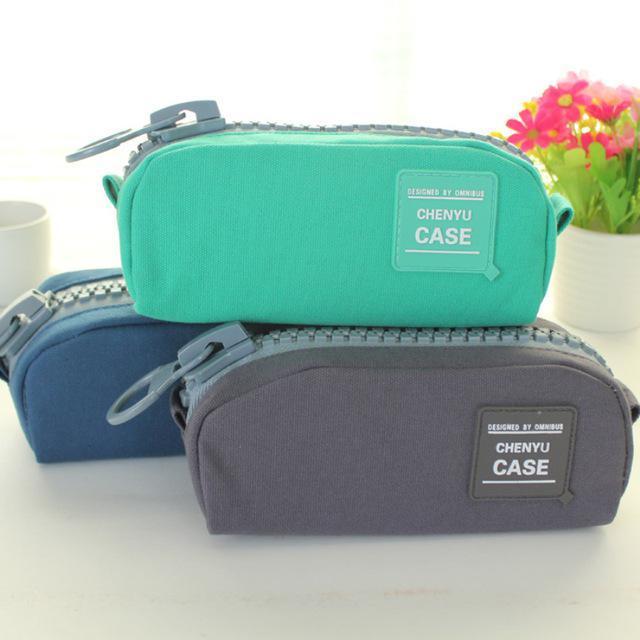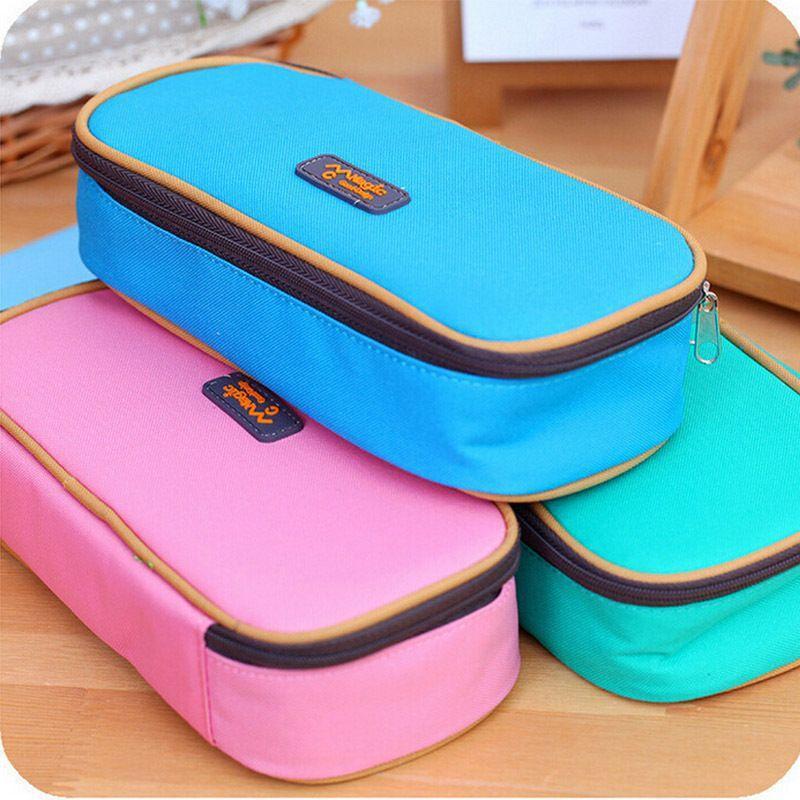The first image is the image on the left, the second image is the image on the right. Examine the images to the left and right. Is the description "At leat one container is green." accurate? Answer yes or no. Yes. 